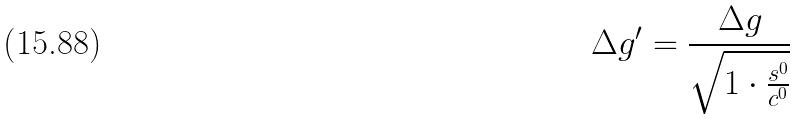Convert formula to latex. <formula><loc_0><loc_0><loc_500><loc_500>\Delta g ^ { \prime } = \frac { \Delta g } { \sqrt { 1 \cdot \frac { s ^ { 0 } } { c ^ { 0 } } } }</formula> 